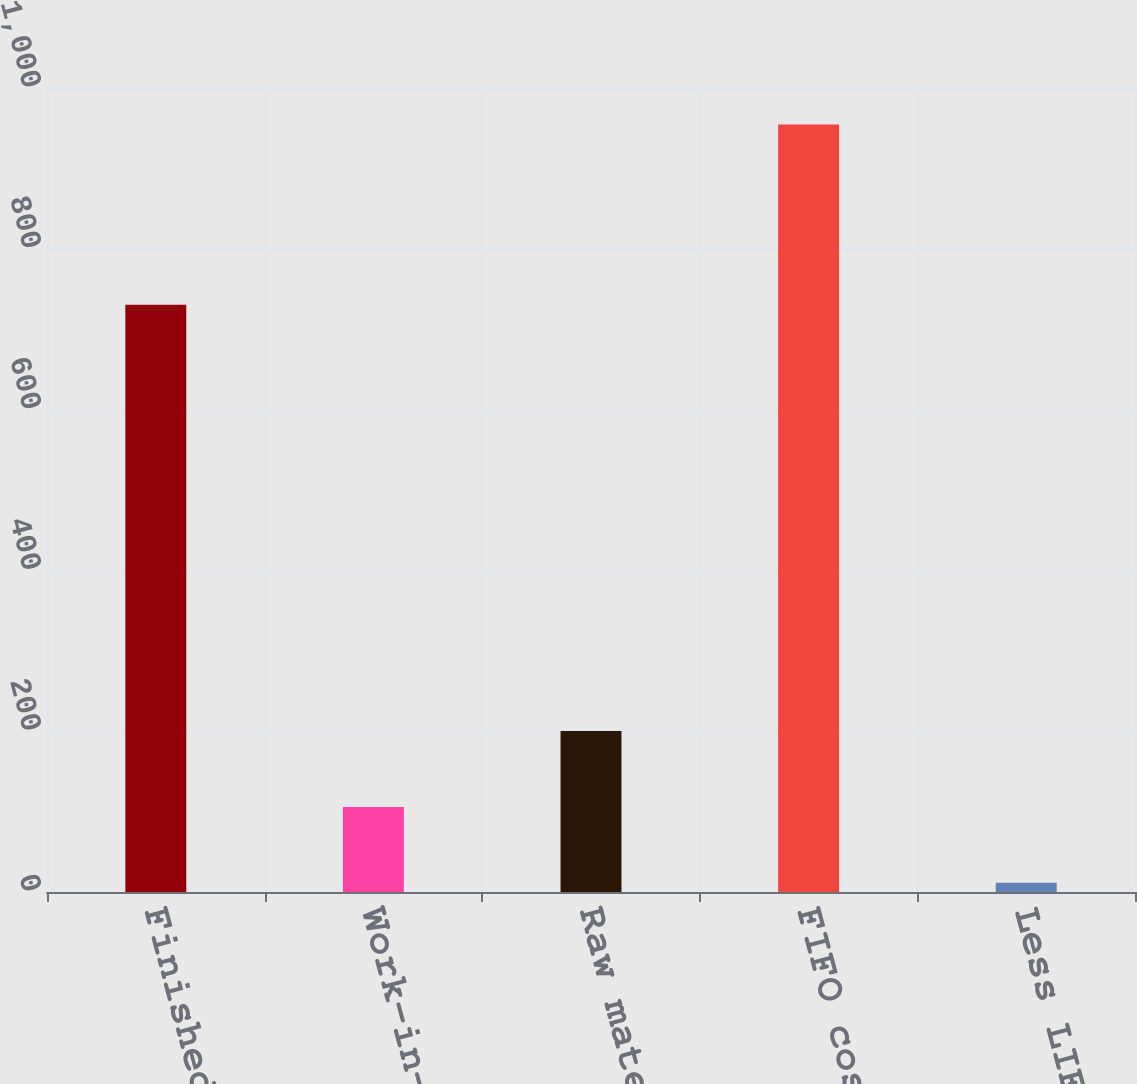Convert chart. <chart><loc_0><loc_0><loc_500><loc_500><bar_chart><fcel>Finished goods<fcel>Work-in-process<fcel>Raw materials<fcel>FIFO cost<fcel>Less LIFO reserve<nl><fcel>730.4<fcel>105.8<fcel>200.1<fcel>954.5<fcel>11.5<nl></chart> 